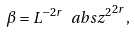Convert formula to latex. <formula><loc_0><loc_0><loc_500><loc_500>\beta = L ^ { - 2 r } \ a b s { z ^ { 2 } } ^ { 2 r } ,</formula> 